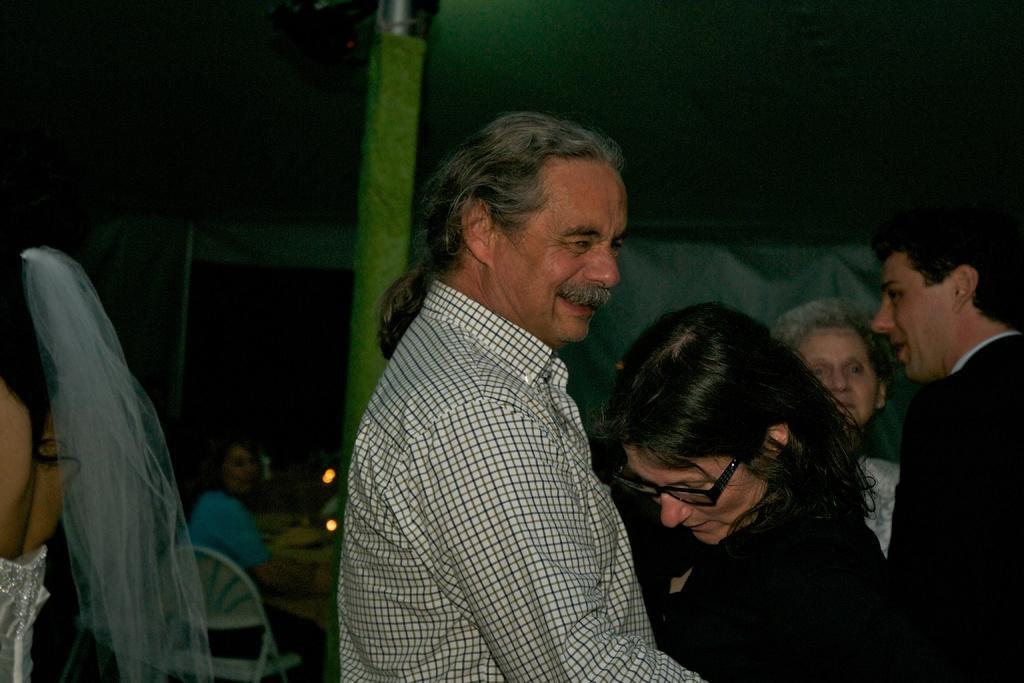Could you give a brief overview of what you see in this image? In this image there are people standing, in the background there are people sitting on chairs and there is a pole, at the top there is a roof. 